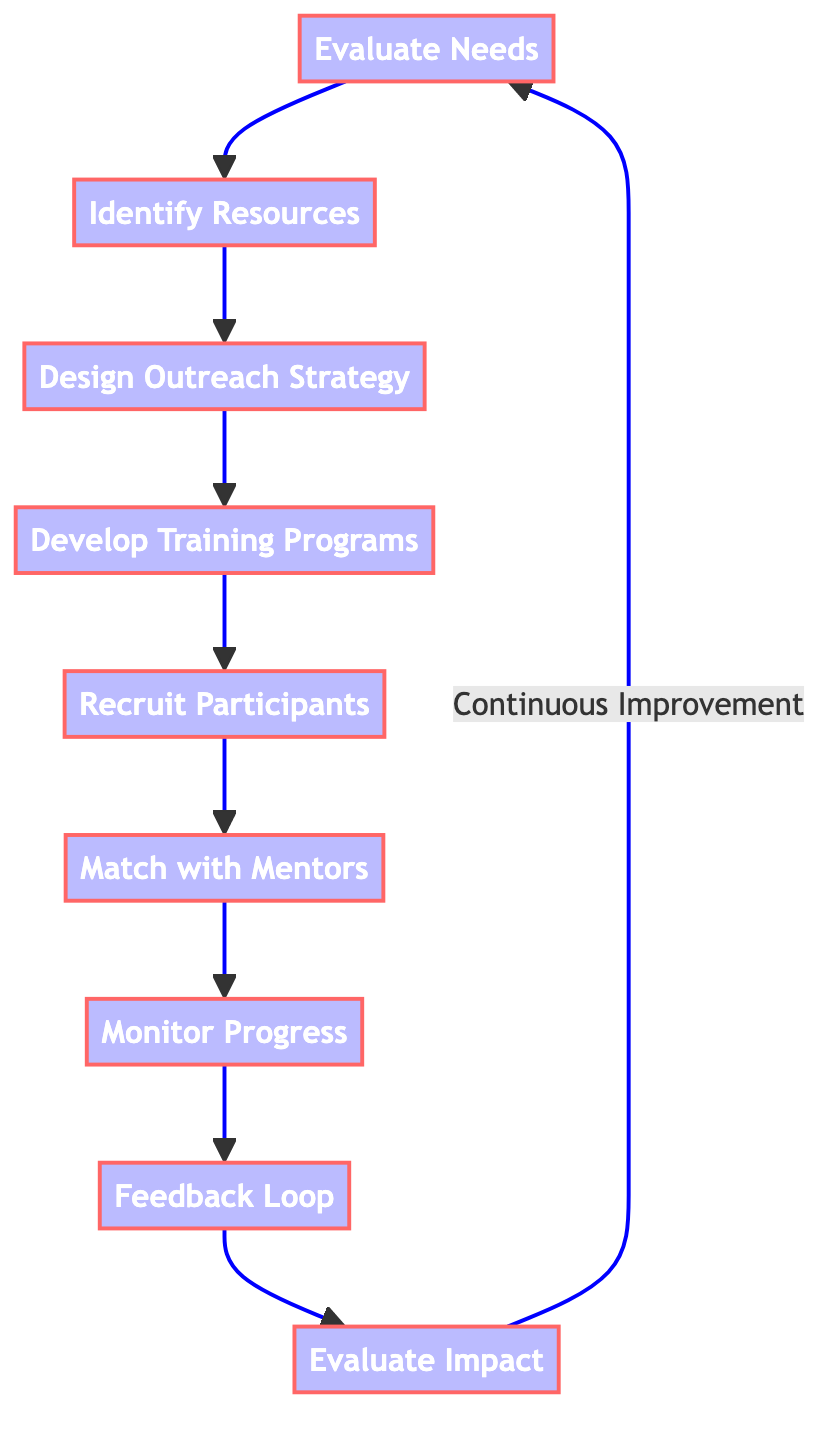What is the first step in the outreach program? The first step in the outreach program is "Evaluate Needs," which involves analyzing the unique needs and challenges faced by recovering addicts.
Answer: Evaluate Needs How many steps are there in this flowchart? The flowchart consists of nine steps, each representing a key component of the outreach program.
Answer: 9 Which step comes after "Design Outreach Strategy"? After "Design Outreach Strategy," the next step is "Develop Training Programs," where training modules are created.
Answer: Develop Training Programs What is the final step in the outreach program? The final step in the program is "Evaluate Impact," where the success of the program is measured by evaluating participants' growth.
Answer: Evaluate Impact What type of feedback is collected in the "Feedback Loop"? The feedback collected in the "Feedback Loop" comes from both participants and mentors, aimed at continuously improving the outreach program.
Answer: Feedback Which steps involve participant engagement or recruitment? The steps involving participant engagement or recruitment include "Recruit Participants" and "Match with Mentors."
Answer: Recruit Participants, Match with Mentors How does the flowchart indicate the importance of continuous improvement? The flowchart indicates the importance of continuous improvement by showing that "Evaluate Impact" leads back to "Evaluate Needs," suggesting that assessment leads to re-evaluation.
Answer: Continuous Improvement What directly follows the "Monitor Progress" step? The step that directly follows "Monitor Progress" is "Feedback Loop;" after monitoring, feedback is collected for adjustment.
Answer: Feedback Loop Which step involves compiling resources like mentorship programs and financial assistance? The step involving compiling resources is "Identify Resources," focusing on creating a list of available support systems.
Answer: Identify Resources 